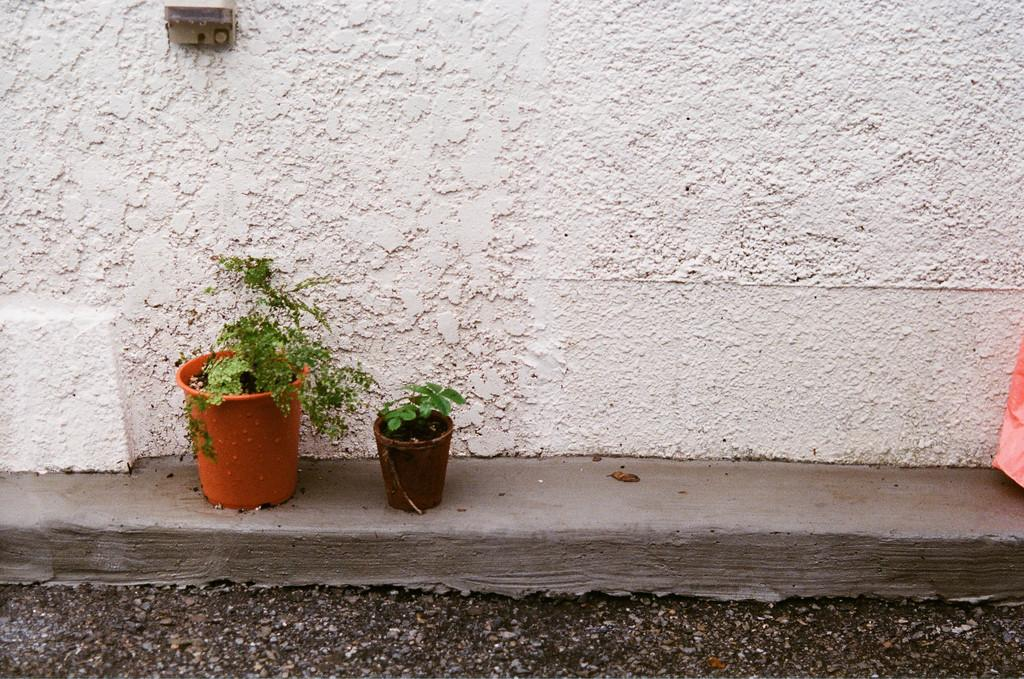What type of material is used to construct the wall in the image? The wall in the image is made of cement. What other objects can be seen in the image besides the wall? There are two house plants in the image. What is the color of the wall in the background of the image? The wall in the background of the image is white. Can you hear a whistle in the image? There is no whistle present in the image, as it is a still image and cannot produce sound. 